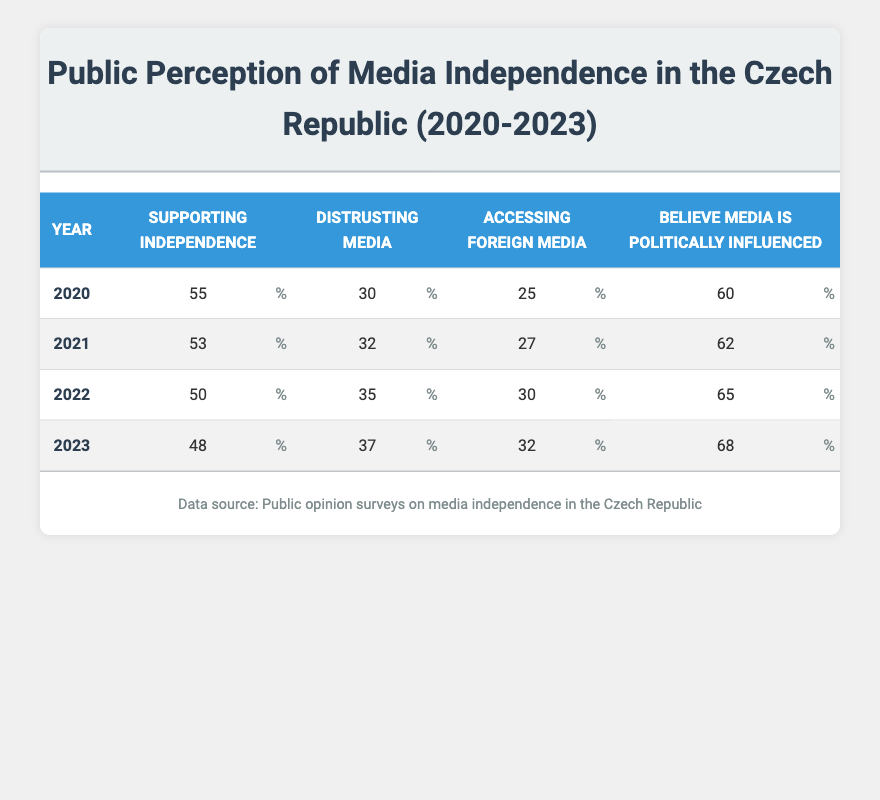What percentage of the public supported media independence in 2020? According to the table, the percentage supporting media independence in 2020 is listed directly in that row as 55%.
Answer: 55% What is the percentage of people who believe that media is influenced by politics in 2023? The table shows that in 2023, the percentage of people who believe media is influenced by politics is listed as 68%.
Answer: 68% What was the trend in the percentage of people accessing foreign media from 2020 to 2023? The percentages for accessing foreign media in each year are: 25% (2020), 27% (2021), 30% (2022), and 32% (2023). This shows an increasing trend over the four years.
Answer: Increasing What was the average percentage of people who distrusted media across all four years? To find the average, we sum the percentages of distrust from each year: 30% (2020) + 32% (2021) + 35% (2022) + 37% (2023) = 134%. Then we divide by the number of years, which is 4. Thus, 134% / 4 = 33.5%.
Answer: 33.5% Is it true that the percentage of people supporting media independence decreased from 2020 to 2023? Yes, looking at the table, we see that the percentage of supporting media independence went from 55% in 2020 to 48% in 2023, confirming a decrease.
Answer: Yes In which year did the highest percentage of people believe that media was politically influenced? From the table, we can see that the highest percentage of people believing media was influenced by politics occurred in 2023, at 68%.
Answer: 2023 What was the decrease in the percentage of people supporting media independence from 2020 to 2022? The percentage of supporting media independence dropped from 55% in 2020 to 50% in 2022, resulting in a decrease of 5%.
Answer: 5% Which year had the highest percentage of people accessing foreign media, and what was that percentage? By reviewing the table, the year with the highest percentage of people accessing foreign media is 2023, with a percentage of 32%.
Answer: 2023, 32% 